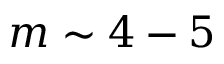<formula> <loc_0><loc_0><loc_500><loc_500>m \sim 4 - 5</formula> 